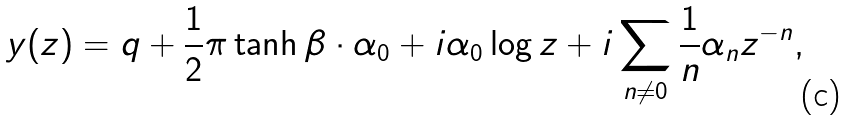<formula> <loc_0><loc_0><loc_500><loc_500>y ( z ) = q + \frac { 1 } { 2 } \pi \tanh \beta \cdot \alpha _ { 0 } + i \alpha _ { 0 } \log z + i \sum _ { n \neq 0 } \frac { 1 } { n } \alpha _ { n } z ^ { - n } ,</formula> 